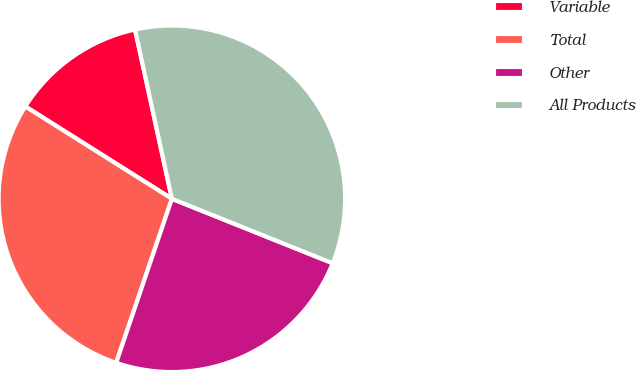Convert chart to OTSL. <chart><loc_0><loc_0><loc_500><loc_500><pie_chart><fcel>Variable<fcel>Total<fcel>Other<fcel>All Products<nl><fcel>12.64%<fcel>28.74%<fcel>24.14%<fcel>34.48%<nl></chart> 